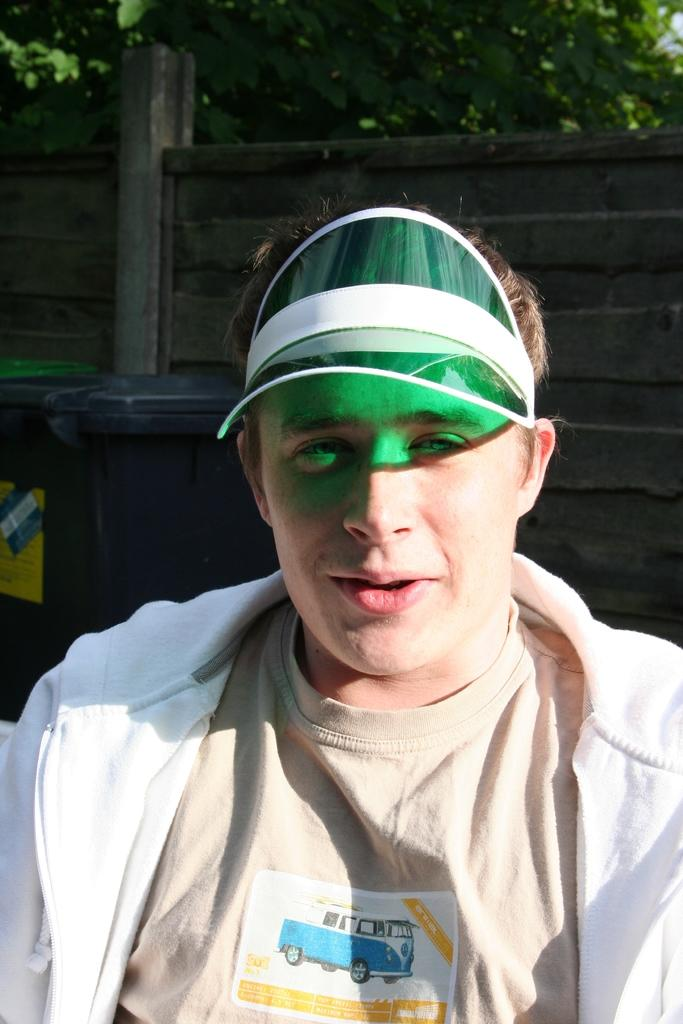What is the man in the image doing? The man is sitting in the image. What is the man wearing on his head? The man is wearing a cap. What object can be seen in the image for disposing of waste? There is a dustbin in the image. What type of wall is visible in the background of the image? There is a wooden wall in the background of the image. What type of vegetation can be seen in the image? There is a tree visible in the image. How many dolls are sitting on the tree in the image? There are no dolls present in the image, and the tree does not have any dolls sitting on it. 